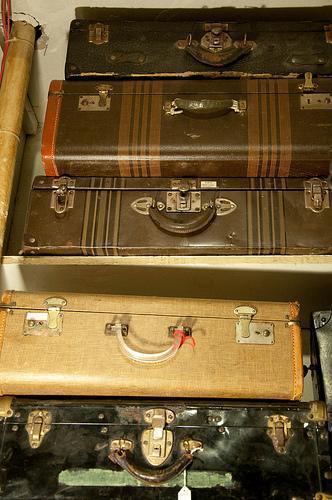How many pieces of luggage are in the picture?
Give a very brief answer. 5. 